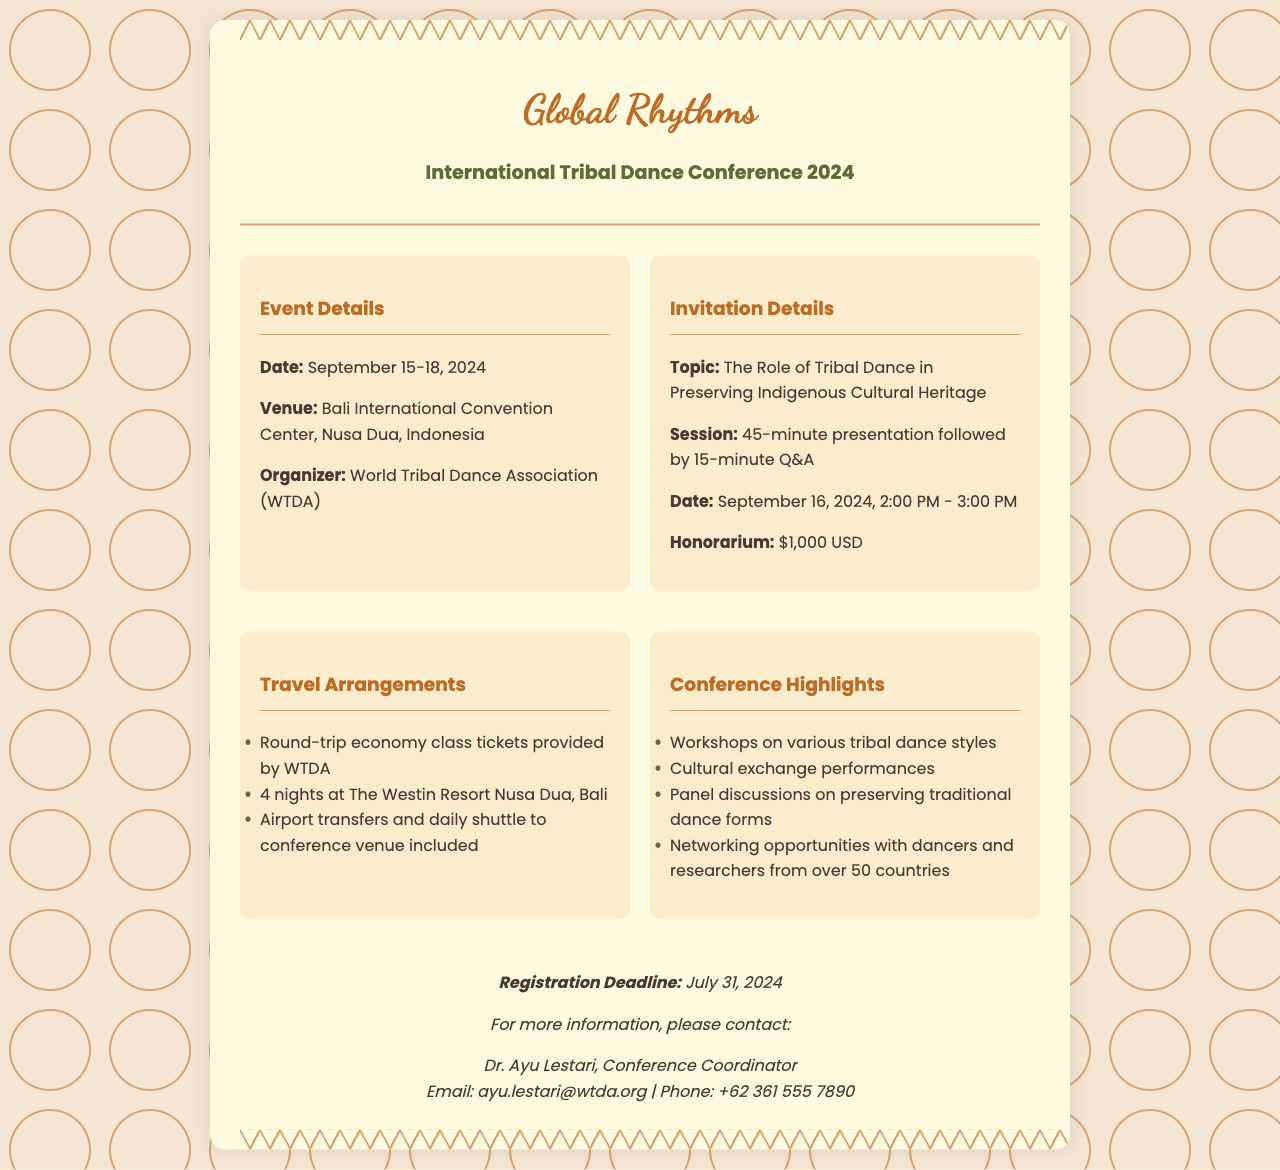What are the conference dates? The conference starts on September 15 and ends on September 18, 2024.
Answer: September 15-18, 2024 Where is the venue located? The document states that the venue is the Bali International Convention Center, Nusa Dua, Indonesia.
Answer: Bali International Convention Center, Nusa Dua, Indonesia What is the topic of the presentation? The document specifies that the presentation will be about "The Role of Tribal Dance in Preserving Indigenous Cultural Heritage."
Answer: The Role of Tribal Dance in Preserving Indigenous Cultural Heritage How long is the presentation session? The session consists of a 45-minute presentation followed by a 15-minute Q&A.
Answer: 45 minutes What is the honorarium amount? The document indicates that the honorarium for participation is $1,000 USD.
Answer: $1,000 USD What accommodations are provided? The document mentions a 4-night stay at The Westin Resort Nusa Dua, Bali.
Answer: The Westin Resort Nusa Dua, Bali Who is the contact person for more information? The document lists Dr. Ayu Lestari as the contact person for the conference.
Answer: Dr. Ayu Lestari What is the registration deadline? According to the document, the registration deadline is July 31, 2024.
Answer: July 31, 2024 How many countries will participants network with at the conference? The document states that there will be networking opportunities with dancers and researchers from over 50 countries.
Answer: Over 50 countries 